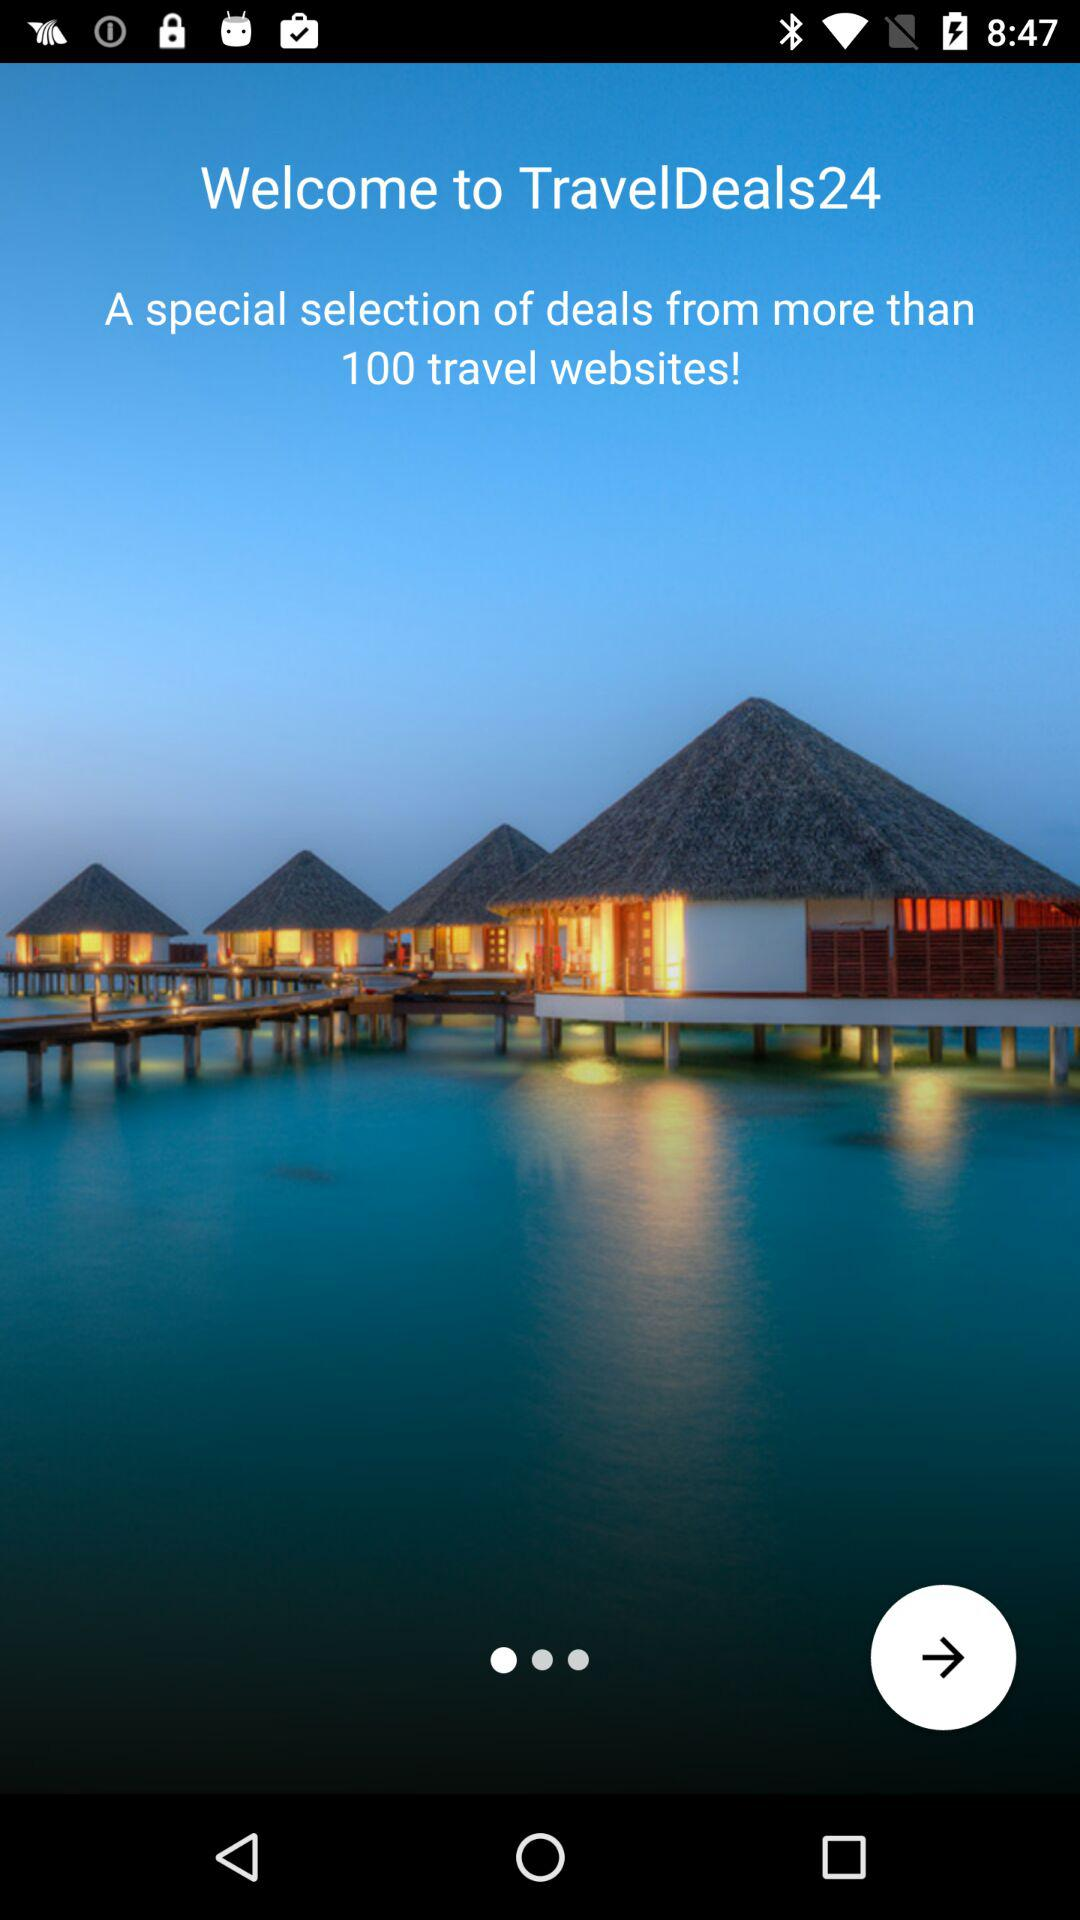What is the name of the application? The name of the application is "TravelDeals24". 